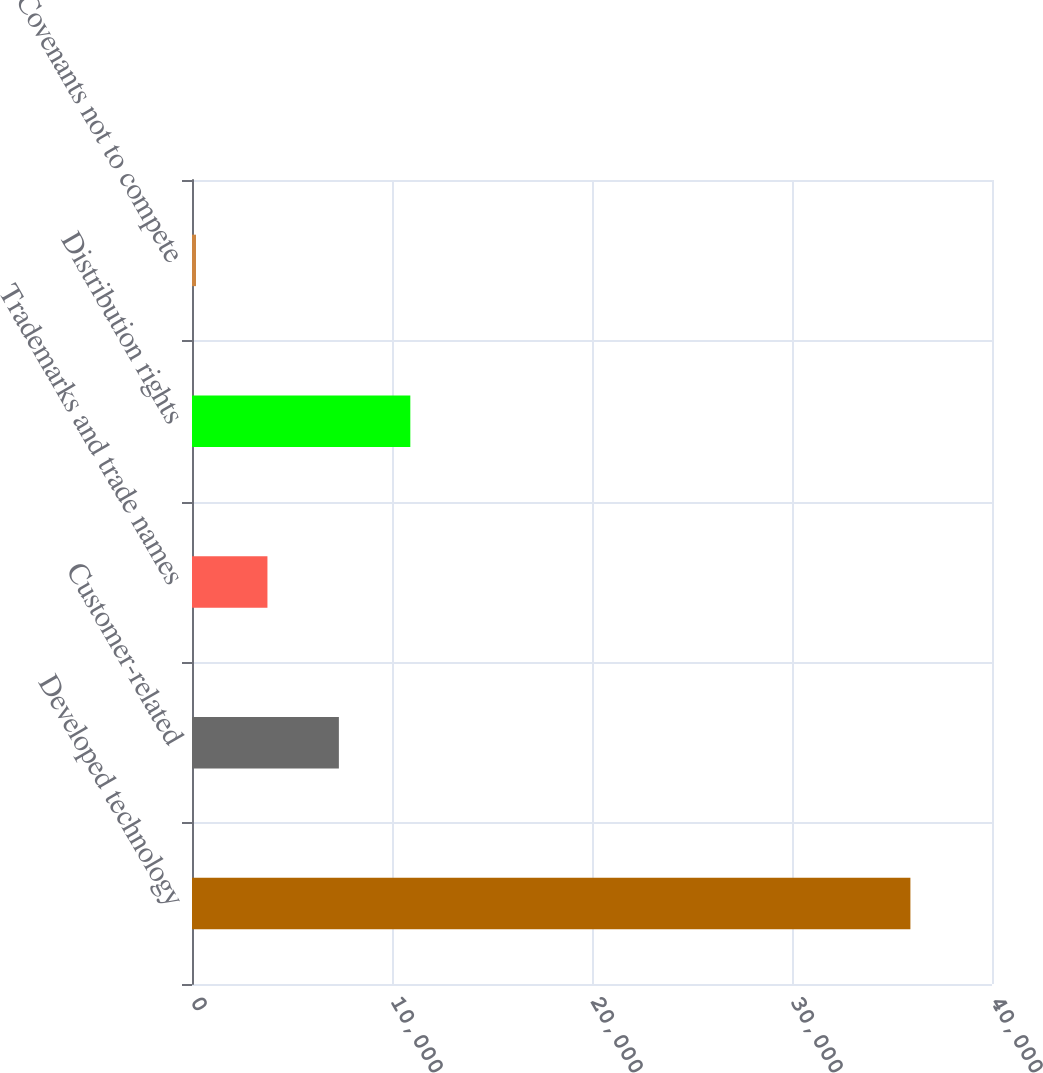<chart> <loc_0><loc_0><loc_500><loc_500><bar_chart><fcel>Developed technology<fcel>Customer-related<fcel>Trademarks and trade names<fcel>Distribution rights<fcel>Covenants not to compete<nl><fcel>35920<fcel>7344<fcel>3772<fcel>10916<fcel>200<nl></chart> 